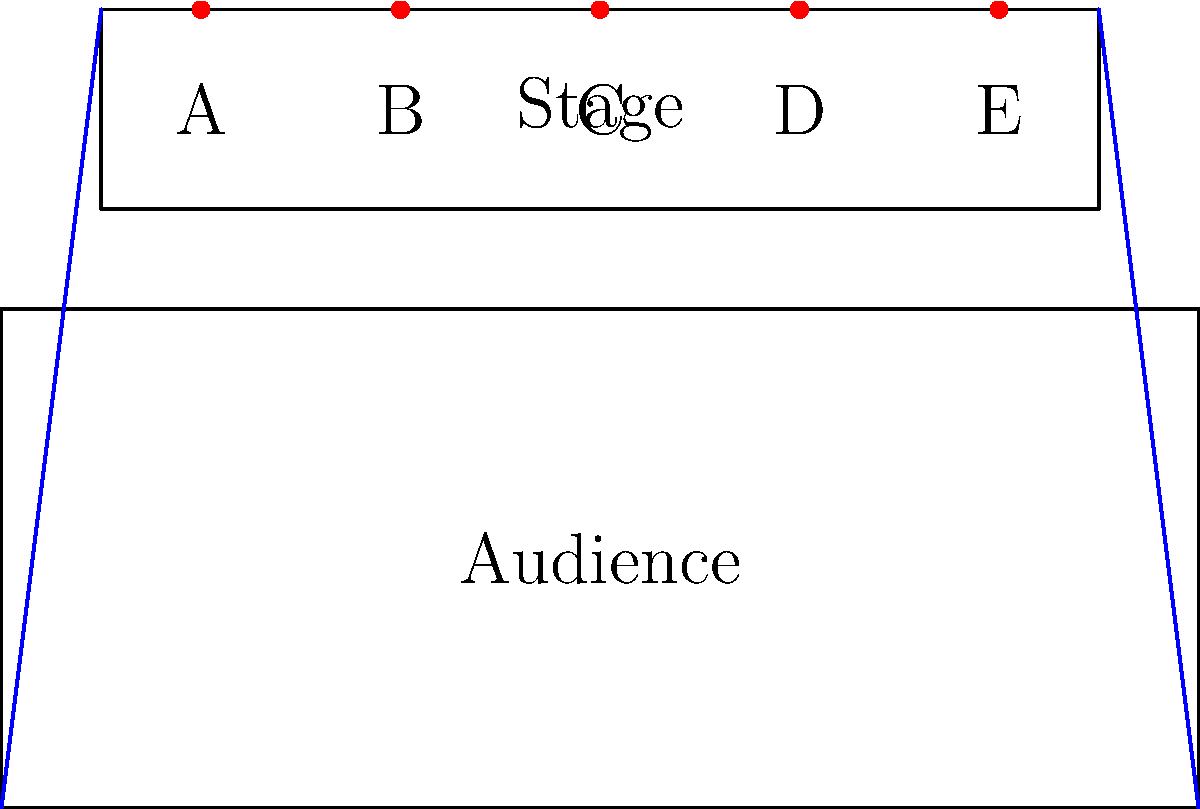Based on the stage layout and audience seating area shown in the diagram, which position (A, B, C, D, or E) would provide the best sight lines for a cabaret performance, ensuring maximum visibility for the entire audience? To determine the best position for optimal sight lines in a cabaret performance, we need to consider the following factors:

1. Central position: A central location on the stage typically provides the best overall visibility for the audience.

2. Distance from the audience: The performer should be close enough to engage with the audience but not too close to limit visibility for those in the front rows.

3. Angle of view: The position should minimize extreme viewing angles for audience members on the sides.

4. Stage depth: Utilizing the depth of the stage can create a more dynamic performance space.

Analyzing the options:

A: Too far to the left, creating extreme angles for the right side of the audience.
B: Slightly off-center, but still a good position with balanced sight lines.
C: Central position, offering the most balanced view for all audience members.
D: Slightly off-center, but still a good position with balanced sight lines.
E: Too far to the right, creating extreme angles for the left side of the audience.

Position C provides the most balanced and optimal sight lines for the entire audience. It is centrally located, allowing for equal visibility from both sides of the audience. This position also utilizes the stage depth effectively, creating a focal point that is neither too close nor too far from the audience.
Answer: C 